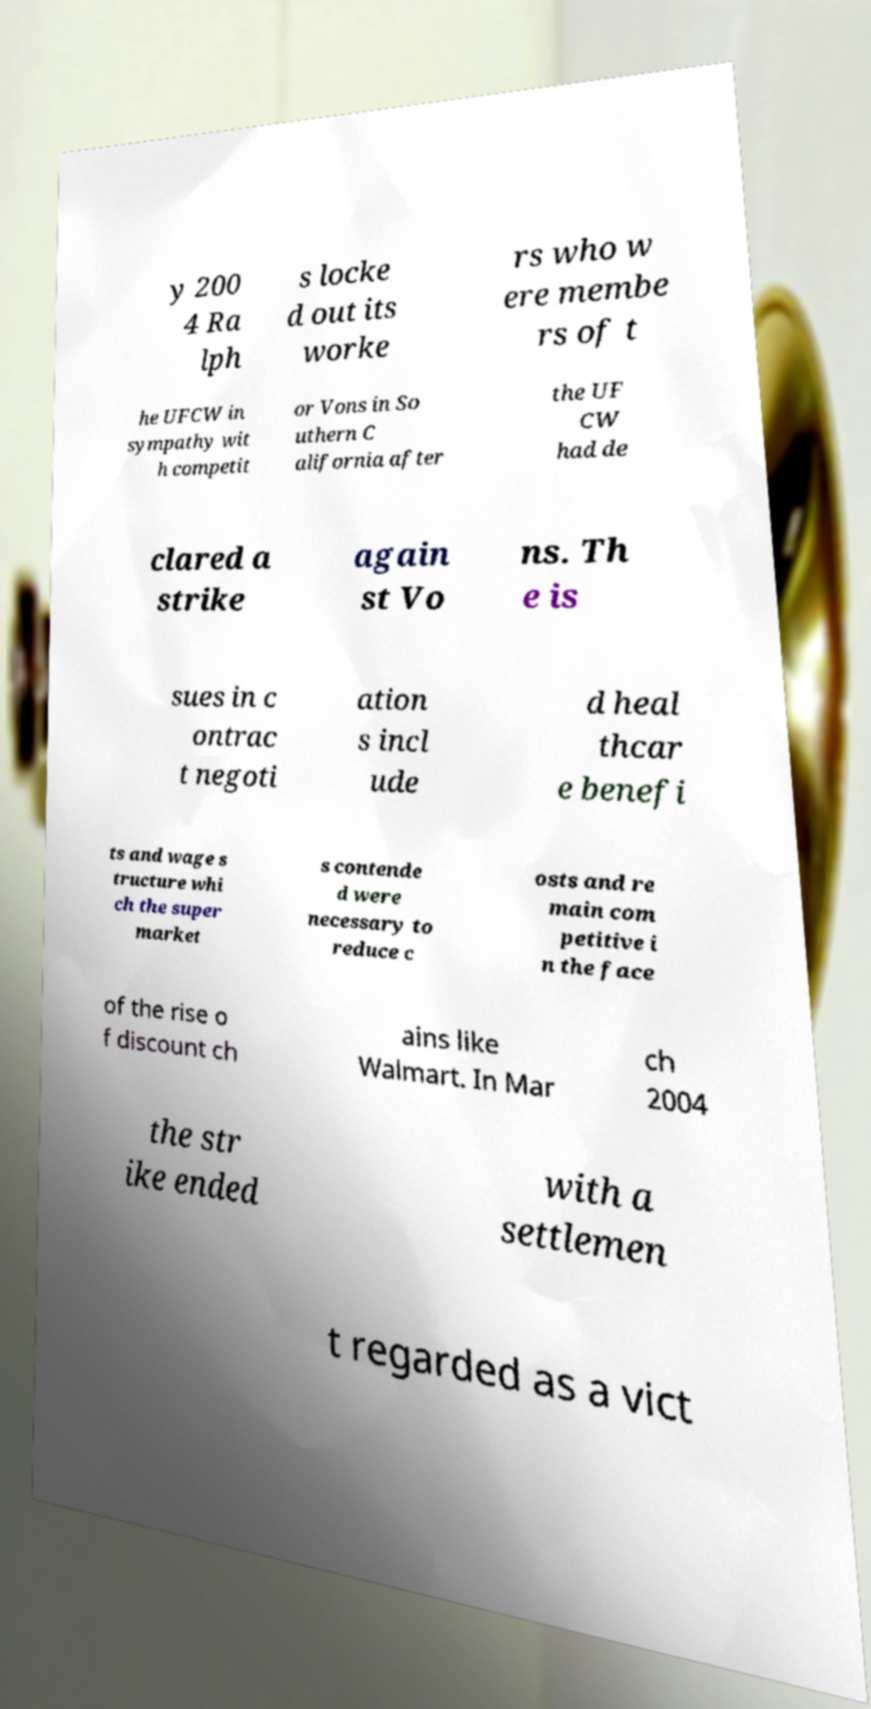For documentation purposes, I need the text within this image transcribed. Could you provide that? y 200 4 Ra lph s locke d out its worke rs who w ere membe rs of t he UFCW in sympathy wit h competit or Vons in So uthern C alifornia after the UF CW had de clared a strike again st Vo ns. Th e is sues in c ontrac t negoti ation s incl ude d heal thcar e benefi ts and wage s tructure whi ch the super market s contende d were necessary to reduce c osts and re main com petitive i n the face of the rise o f discount ch ains like Walmart. In Mar ch 2004 the str ike ended with a settlemen t regarded as a vict 